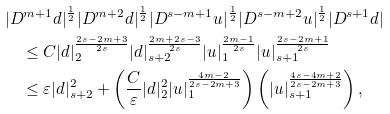Convert formula to latex. <formula><loc_0><loc_0><loc_500><loc_500>& | D ^ { m + 1 } d | ^ { \frac { 1 } { 2 } } | D ^ { m + 2 } d | ^ { \frac { 1 } { 2 } } | D ^ { s - m + 1 } u | ^ { \frac { 1 } { 2 } } | D ^ { s - m + 2 } u | ^ { \frac { 1 } { 2 } } | D ^ { s + 1 } d | \\ & \quad \leq C | d | _ { 2 } ^ { \frac { 2 s - 2 m + 3 } { 2 s } } | d | _ { s + 2 } ^ { \frac { 2 m + 2 s - 3 } { 2 s } } | u | _ { 1 } ^ { \frac { 2 m - 1 } { 2 s } } | u | _ { s + 1 } ^ { \frac { 2 s - 2 m + 1 } { 2 s } } \\ & \quad \leq \varepsilon | d | _ { s + 2 } ^ { 2 } + \left ( \frac { C } { \varepsilon } | d | ^ { 2 } _ { 2 } | u | _ { 1 } ^ { \frac { 4 m - 2 } { 2 s - 2 m + 3 } } \right ) \left ( | u | _ { s + 1 } ^ { \frac { 4 s - 4 m + 2 } { 2 s - 2 m + 3 } } \right ) ,</formula> 